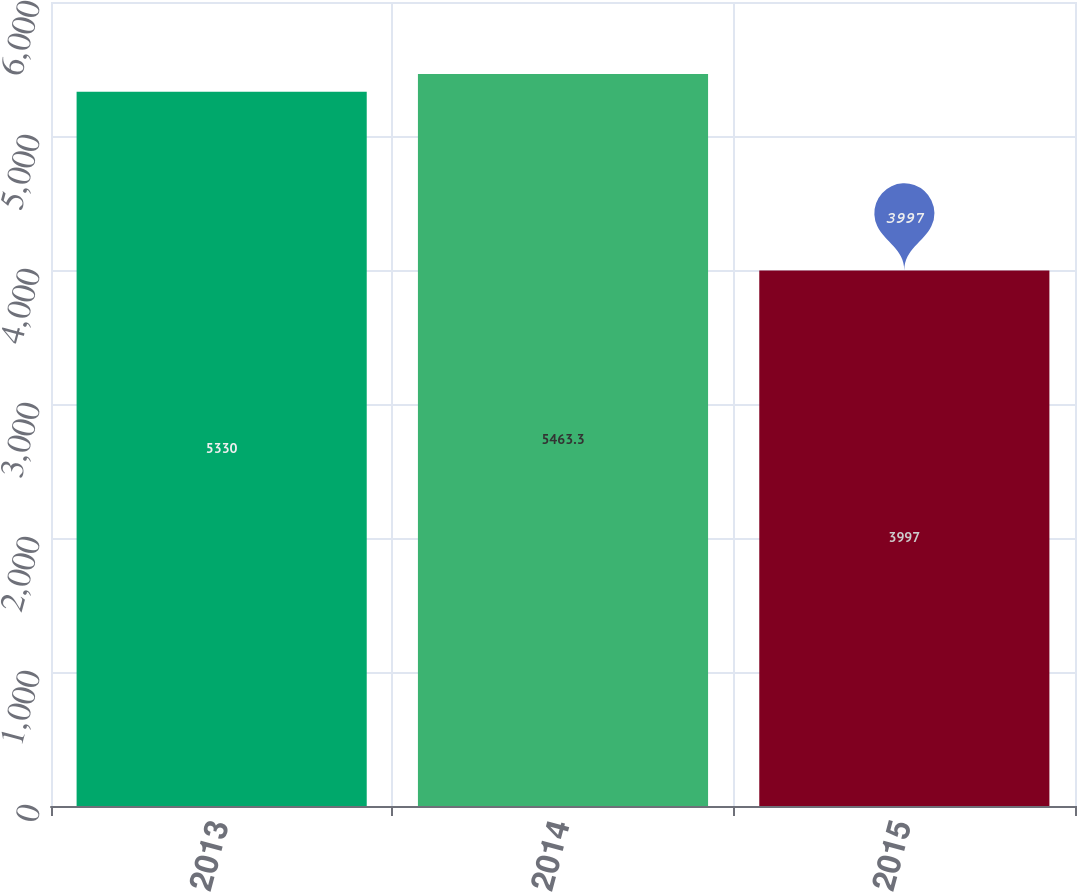Convert chart. <chart><loc_0><loc_0><loc_500><loc_500><bar_chart><fcel>2013<fcel>2014<fcel>2015<nl><fcel>5330<fcel>5463.3<fcel>3997<nl></chart> 